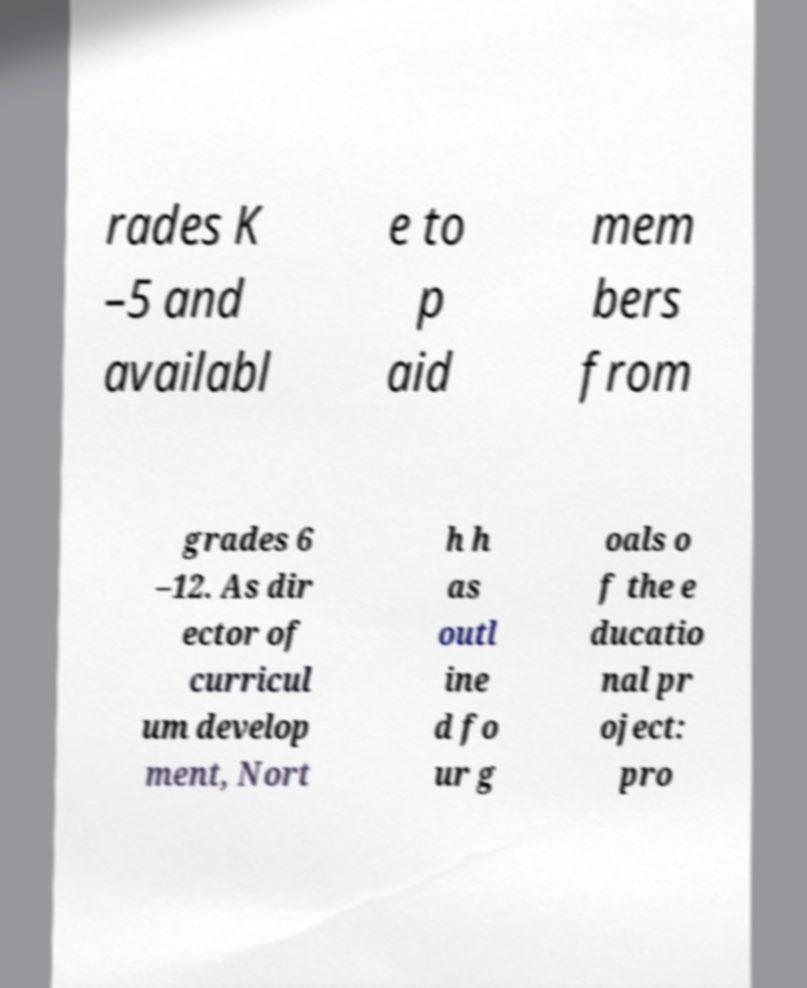Please identify and transcribe the text found in this image. rades K –5 and availabl e to p aid mem bers from grades 6 –12. As dir ector of curricul um develop ment, Nort h h as outl ine d fo ur g oals o f the e ducatio nal pr oject: pro 